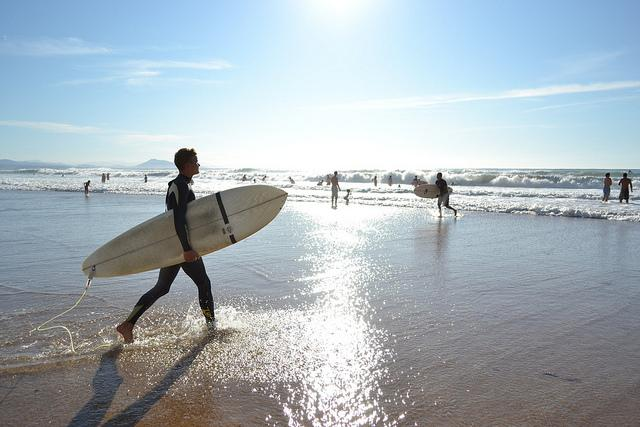What is the man walking to?

Choices:
A) ocean
B) pond
C) river
D) lake ocean 